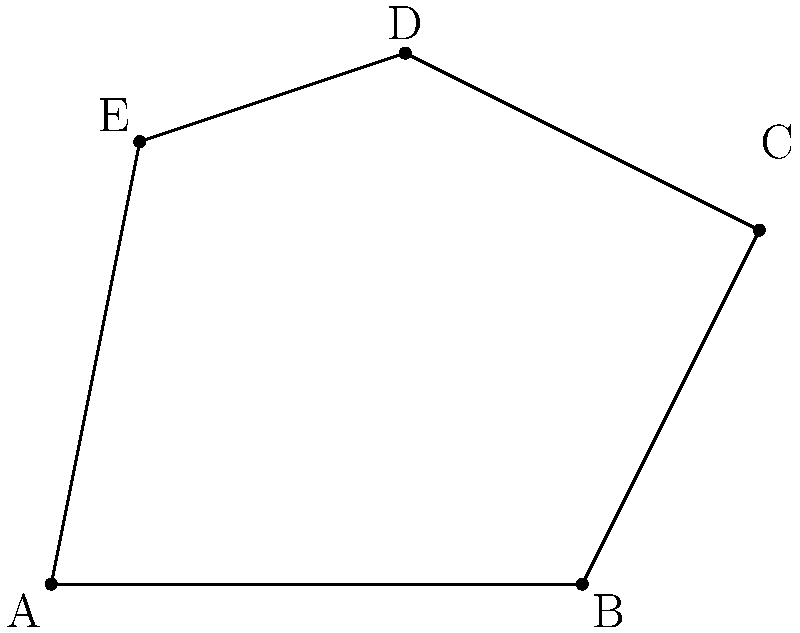As a member of the Citizens for Animal Protection, you've been tasked with determining the area of an irregularly shaped animal enclosure. The enclosure is represented by the polygon ABCDE in the coordinate plane. Calculate the area of this enclosure using coordinate geometry.

Coordinates:
A(0,0), B(6,0), C(8,4), D(4,6), E(1,5) To find the area of the irregular polygon, we can use the Shoelace formula (also known as the surveyor's formula). The steps are as follows:

1) The Shoelace formula for a polygon with vertices $(x_1, y_1), (x_2, y_2), ..., (x_n, y_n)$ is:

   Area = $\frac{1}{2}|(x_1y_2 + x_2y_3 + ... + x_ny_1) - (y_1x_2 + y_2x_3 + ... + y_nx_1)|$

2) Let's arrange our coordinates in order:
   A(0,0), B(6,0), C(8,4), D(4,6), E(1,5)

3) Now, let's apply the formula:

   Area = $\frac{1}{2}|[(0 \cdot 0) + (6 \cdot 4) + (8 \cdot 6) + (4 \cdot 5) + (1 \cdot 0)] - [(0 \cdot 6) + (0 \cdot 8) + (4 \cdot 4) + (6 \cdot 1) + (5 \cdot 0)]|$

4) Simplify:
   Area = $\frac{1}{2}|[0 + 24 + 48 + 20 + 0] - [0 + 0 + 16 + 6 + 0]|$
   
5) Calculate:
   Area = $\frac{1}{2}|92 - 22|$
   Area = $\frac{1}{2}|70|$
   Area = 35

Therefore, the area of the animal enclosure is 35 square units.
Answer: 35 square units 